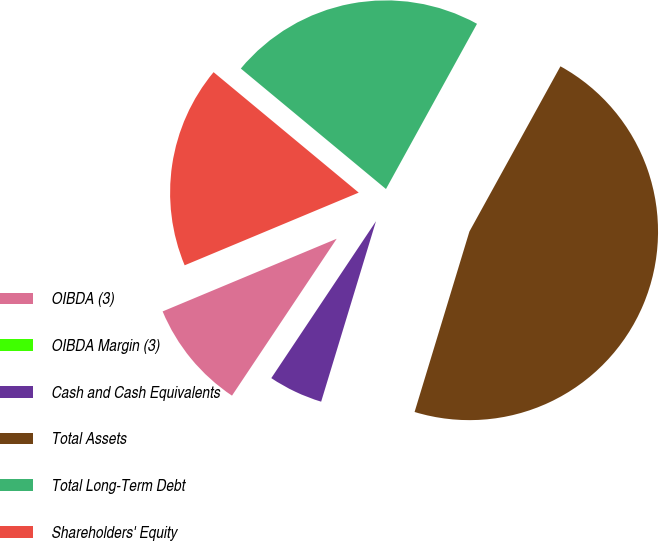Convert chart. <chart><loc_0><loc_0><loc_500><loc_500><pie_chart><fcel>OIBDA (3)<fcel>OIBDA Margin (3)<fcel>Cash and Cash Equivalents<fcel>Total Assets<fcel>Total Long-Term Debt<fcel>Shareholders' Equity<nl><fcel>9.34%<fcel>0.0%<fcel>4.67%<fcel>46.68%<fcel>21.99%<fcel>17.32%<nl></chart> 